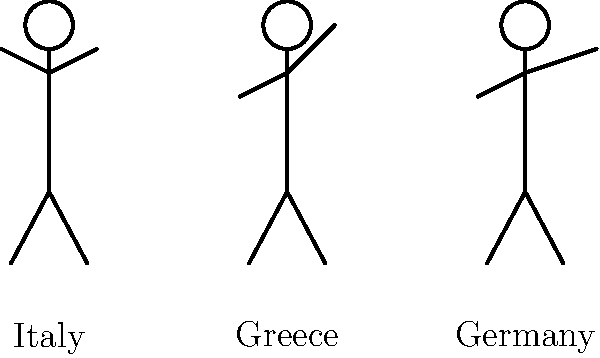In your mystery novel set across Europe, your protagonist encounters three locals performing different gestures. Based on the stick figure illustrations representing common gestures in Italy, Greece, and Germany, which gesture might be misinterpreted as offensive or rude if used in the wrong cultural context? To answer this question, we need to analyze the gestures shown in the stick figure illustrations and consider their cultural significance in different European countries:

1. Italy (left figure): The figure is shown shrugging, which is generally a universal gesture for uncertainty or lack of knowledge. This gesture is not typically considered offensive in most European cultures.

2. Greece (middle figure): The figure is giving a thumbs-up sign. While this is generally positive in many Western cultures, it can be considered offensive or vulgar in some Mediterranean countries, including Greece. In Greek culture, the thumbs-up gesture is similar to "giving the middle finger" in other cultures.

3. Germany (right figure): The figure is shown waving, which is a common greeting gesture in most cultures and is not typically considered offensive.

Among these three gestures, the thumbs-up sign used in Greece is the most likely to be misinterpreted as offensive or rude if used in the wrong cultural context. While it's a positive gesture in many countries, it can be seen as vulgar or insulting in Greece and some other Mediterranean countries.

For a mystery novelist seeking accurate translations and cultural representations, it's crucial to be aware of such cultural differences in gestures to avoid unintended offense or misunderstandings in character dialogues and interactions.
Answer: Thumbs-up in Greece 